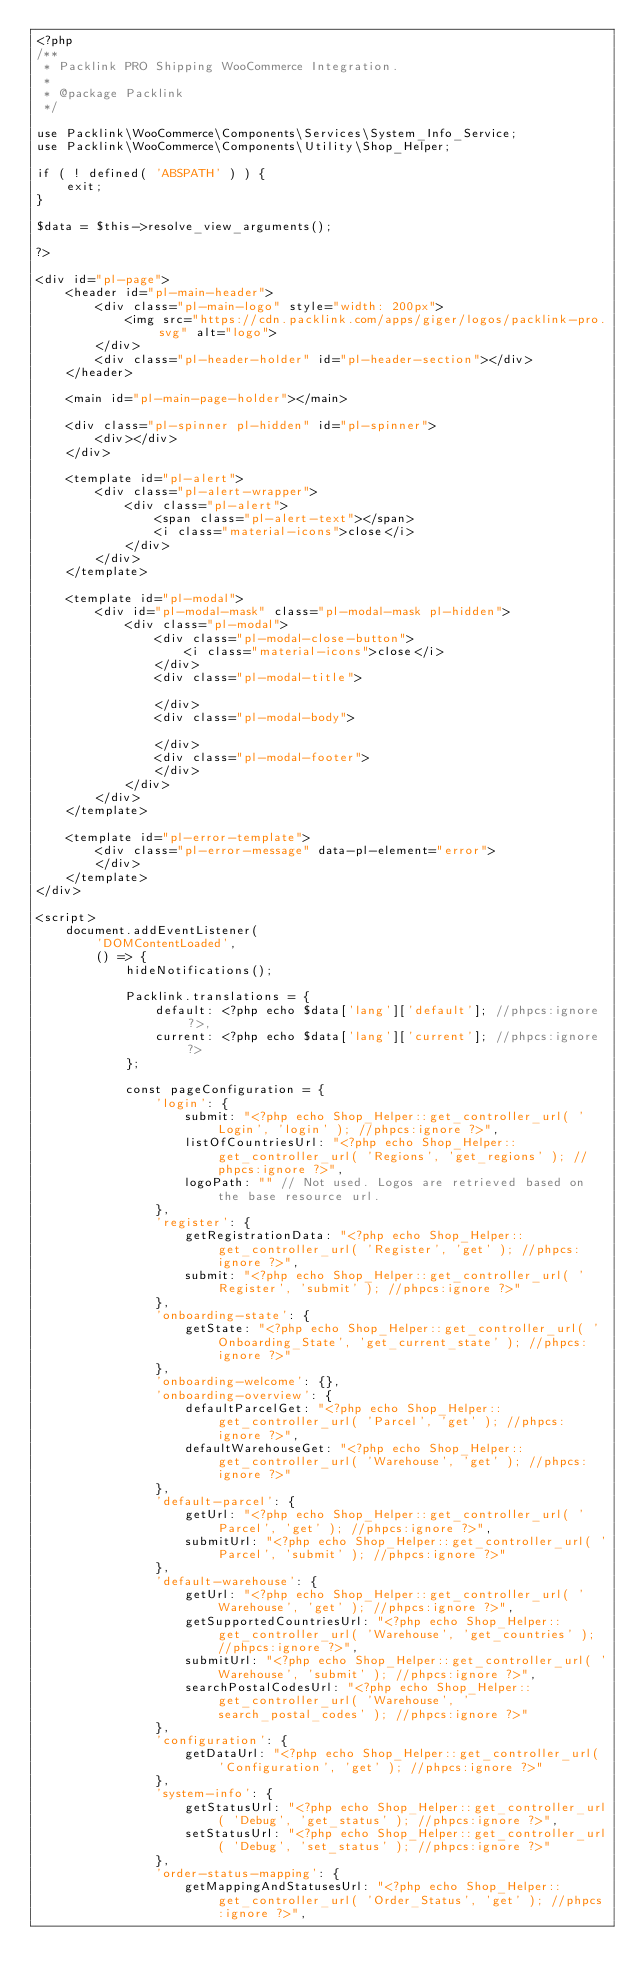<code> <loc_0><loc_0><loc_500><loc_500><_PHP_><?php
/**
 * Packlink PRO Shipping WooCommerce Integration.
 *
 * @package Packlink
 */

use Packlink\WooCommerce\Components\Services\System_Info_Service;
use Packlink\WooCommerce\Components\Utility\Shop_Helper;

if ( ! defined( 'ABSPATH' ) ) {
	exit;
}

$data = $this->resolve_view_arguments();

?>

<div id="pl-page">
	<header id="pl-main-header">
		<div class="pl-main-logo" style="width: 200px">
			<img src="https://cdn.packlink.com/apps/giger/logos/packlink-pro.svg" alt="logo">
		</div>
		<div class="pl-header-holder" id="pl-header-section"></div>
	</header>

	<main id="pl-main-page-holder"></main>

	<div class="pl-spinner pl-hidden" id="pl-spinner">
		<div></div>
	</div>

	<template id="pl-alert">
		<div class="pl-alert-wrapper">
			<div class="pl-alert">
				<span class="pl-alert-text"></span>
				<i class="material-icons">close</i>
			</div>
		</div>
	</template>

	<template id="pl-modal">
		<div id="pl-modal-mask" class="pl-modal-mask pl-hidden">
			<div class="pl-modal">
				<div class="pl-modal-close-button">
					<i class="material-icons">close</i>
				</div>
				<div class="pl-modal-title">

				</div>
				<div class="pl-modal-body">

				</div>
				<div class="pl-modal-footer">
				</div>
			</div>
		</div>
	</template>

	<template id="pl-error-template">
		<div class="pl-error-message" data-pl-element="error">
		</div>
	</template>
</div>

<script>
	document.addEventListener(
		'DOMContentLoaded',
		() => {
			hideNotifications();

			Packlink.translations = {
				default: <?php echo $data['lang']['default']; //phpcs:ignore ?>,
				current: <?php echo $data['lang']['current']; //phpcs:ignore ?>
			};

			const pageConfiguration = {
				'login': {
					submit: "<?php echo Shop_Helper::get_controller_url( 'Login', 'login' ); //phpcs:ignore ?>",
					listOfCountriesUrl: "<?php echo Shop_Helper::get_controller_url( 'Regions', 'get_regions' ); //phpcs:ignore ?>",
					logoPath: "" // Not used. Logos are retrieved based on the base resource url.
				},
				'register': {
					getRegistrationData: "<?php echo Shop_Helper::get_controller_url( 'Register', 'get' ); //phpcs:ignore ?>",
					submit: "<?php echo Shop_Helper::get_controller_url( 'Register', 'submit' ); //phpcs:ignore ?>"
				},
				'onboarding-state': {
					getState: "<?php echo Shop_Helper::get_controller_url( 'Onboarding_State', 'get_current_state' ); //phpcs:ignore ?>"
				},
				'onboarding-welcome': {},
				'onboarding-overview': {
					defaultParcelGet: "<?php echo Shop_Helper::get_controller_url( 'Parcel', 'get' ); //phpcs:ignore ?>",
					defaultWarehouseGet: "<?php echo Shop_Helper::get_controller_url( 'Warehouse', 'get' ); //phpcs:ignore ?>"
				},
				'default-parcel': {
					getUrl: "<?php echo Shop_Helper::get_controller_url( 'Parcel', 'get' ); //phpcs:ignore ?>",
					submitUrl: "<?php echo Shop_Helper::get_controller_url( 'Parcel', 'submit' ); //phpcs:ignore ?>"
				},
				'default-warehouse': {
					getUrl: "<?php echo Shop_Helper::get_controller_url( 'Warehouse', 'get' ); //phpcs:ignore ?>",
					getSupportedCountriesUrl: "<?php echo Shop_Helper::get_controller_url( 'Warehouse', 'get_countries' ); //phpcs:ignore ?>",
					submitUrl: "<?php echo Shop_Helper::get_controller_url( 'Warehouse', 'submit' ); //phpcs:ignore ?>",
					searchPostalCodesUrl: "<?php echo Shop_Helper::get_controller_url( 'Warehouse', 'search_postal_codes' ); //phpcs:ignore ?>"
				},
				'configuration': {
					getDataUrl: "<?php echo Shop_Helper::get_controller_url( 'Configuration', 'get' ); //phpcs:ignore ?>"
				},
				'system-info': {
					getStatusUrl: "<?php echo Shop_Helper::get_controller_url( 'Debug', 'get_status' ); //phpcs:ignore ?>",
					setStatusUrl: "<?php echo Shop_Helper::get_controller_url( 'Debug', 'set_status' ); //phpcs:ignore ?>"
				},
				'order-status-mapping': {
					getMappingAndStatusesUrl: "<?php echo Shop_Helper::get_controller_url( 'Order_Status', 'get' ); //phpcs:ignore ?>",</code> 